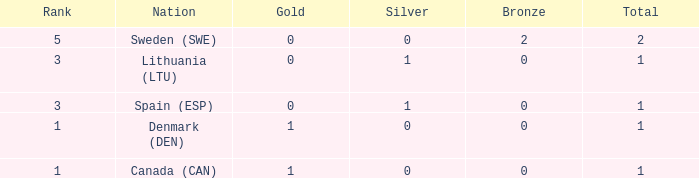What is the total when there were less than 0 bronze? 0.0. 